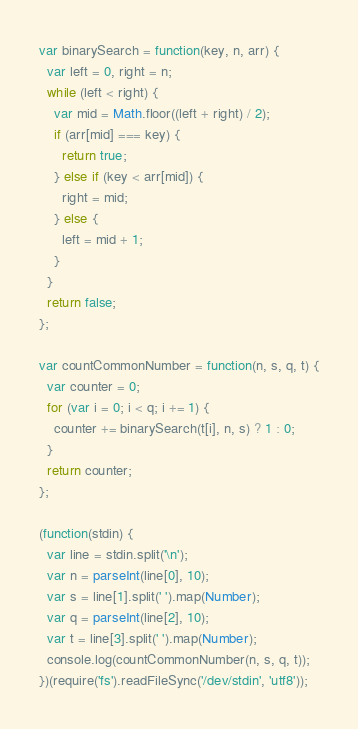Convert code to text. <code><loc_0><loc_0><loc_500><loc_500><_JavaScript_>var binarySearch = function(key, n, arr) {
  var left = 0, right = n;
  while (left < right) {
    var mid = Math.floor((left + right) / 2);
    if (arr[mid] === key) {
      return true;
    } else if (key < arr[mid]) {
      right = mid;
    } else {
      left = mid + 1;
    }
  }
  return false;
};

var countCommonNumber = function(n, s, q, t) {
  var counter = 0;
  for (var i = 0; i < q; i += 1) {
    counter += binarySearch(t[i], n, s) ? 1 : 0;
  }
  return counter;
};

(function(stdin) {
  var line = stdin.split('\n');
  var n = parseInt(line[0], 10);
  var s = line[1].split(' ').map(Number);
  var q = parseInt(line[2], 10);
  var t = line[3].split(' ').map(Number);
  console.log(countCommonNumber(n, s, q, t));
})(require('fs').readFileSync('/dev/stdin', 'utf8'));</code> 